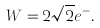<formula> <loc_0><loc_0><loc_500><loc_500>W = 2 \sqrt { 2 } e ^ { - } .</formula> 